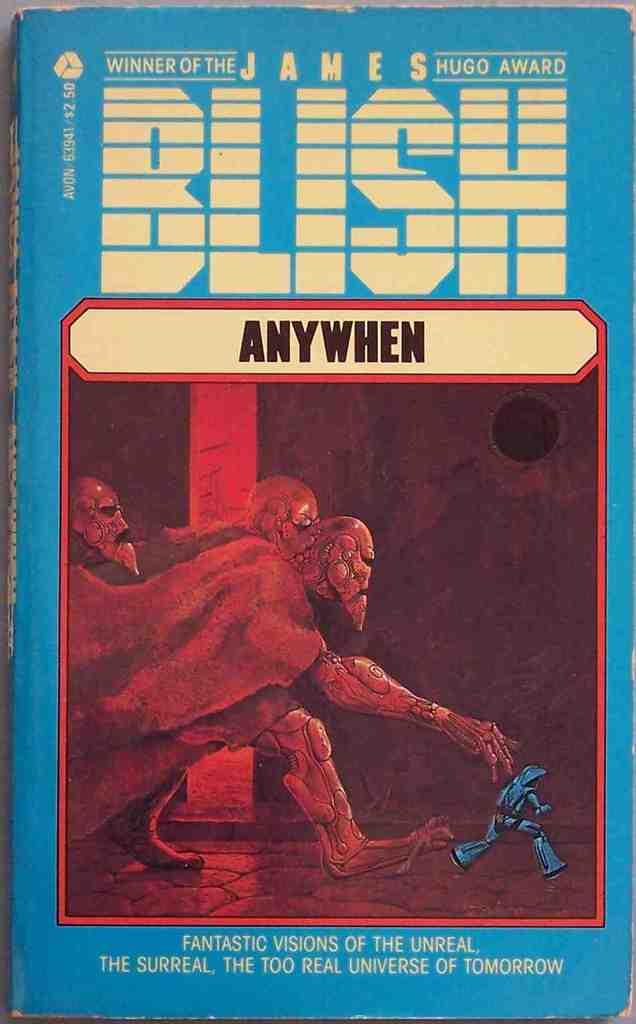Which award did jame blish win?
Give a very brief answer. Hugo. Who is this?
Provide a succinct answer. James blish. 